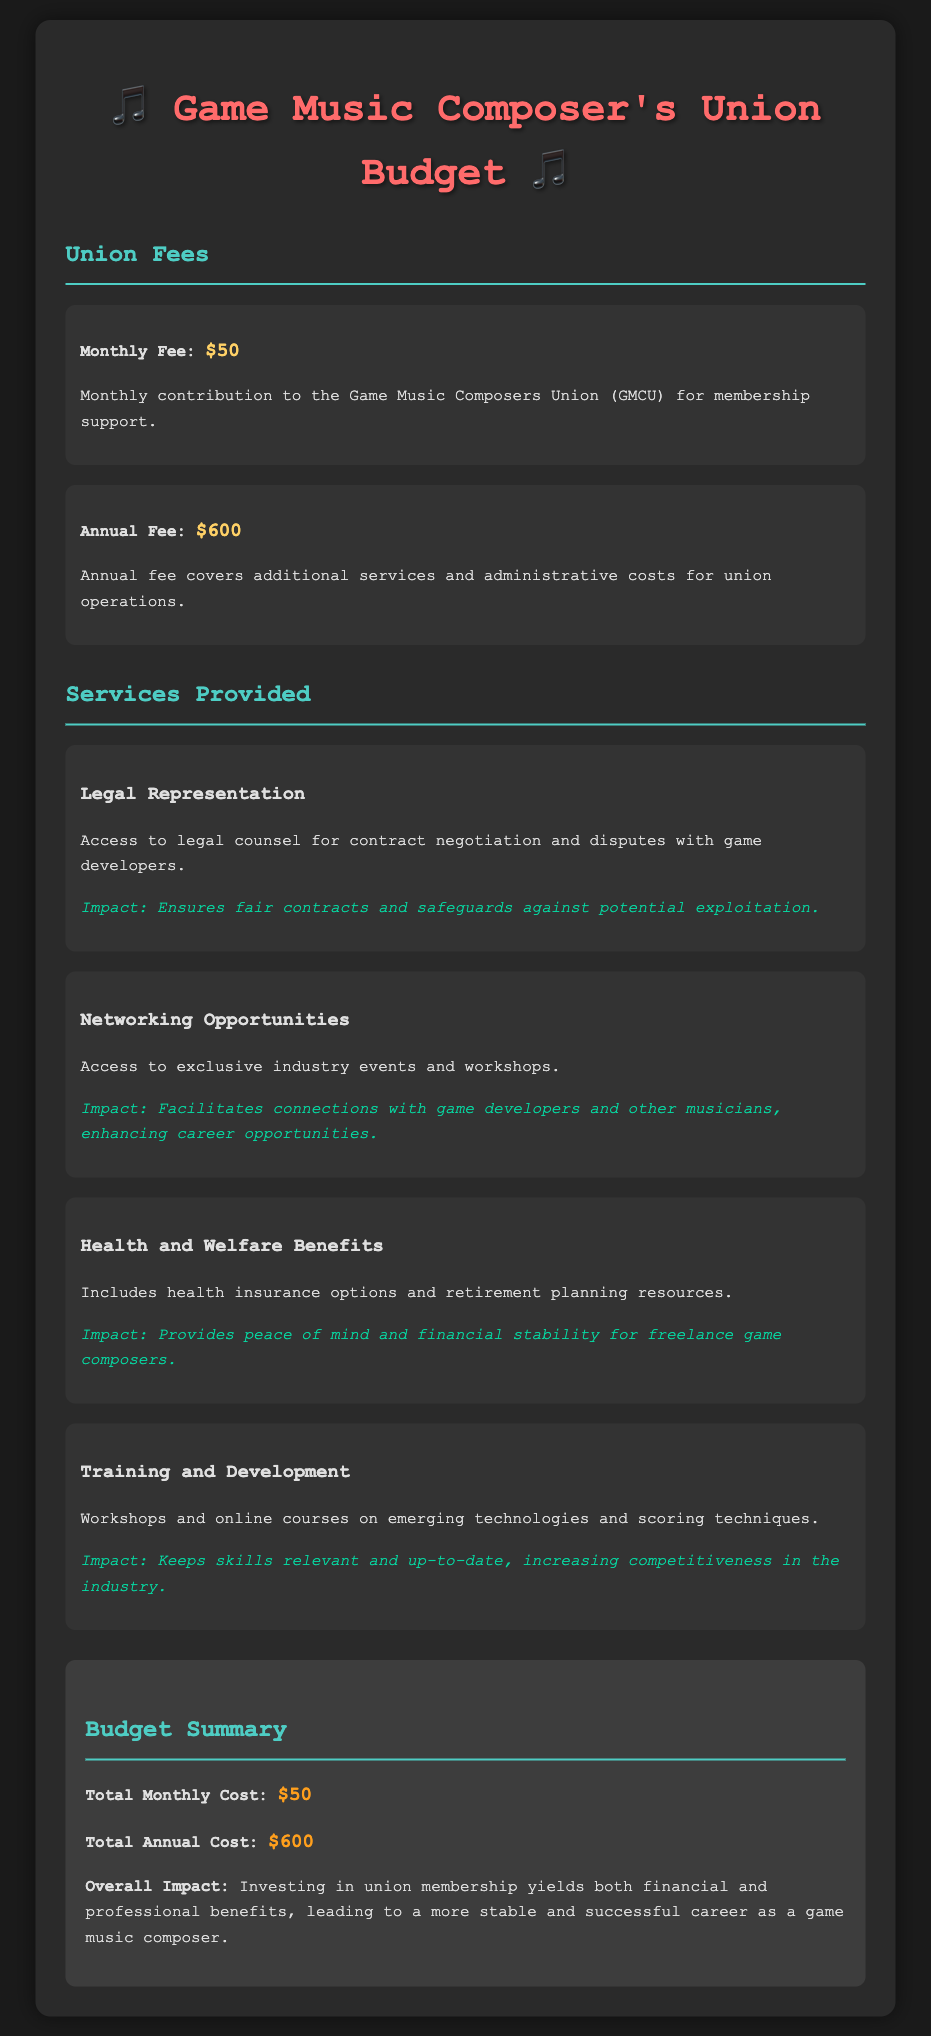What is the monthly fee? The monthly fee is explicitly stated in the document as $50.
Answer: $50 What is the annual fee? The annual fee is detailed in the budget breakdown as $600.
Answer: $600 What type of representation does the union provide? The document mentions "Legal Representation" as a service provided by the union.
Answer: Legal Representation Which benefit includes health insurance options? The health and welfare benefits section covers "Health Insurance options."
Answer: Health and Welfare Benefits What is one impact of networking opportunities? The document indicates that networking opportunities enhance career opportunities.
Answer: Enhances career opportunities How much is the total annual cost? The total annual cost is summarized in the budget as $600.
Answer: $600 What is the overall impact of investing in union membership? The document states that investing in union membership leads to a more stable and successful career.
Answer: More stable and successful career Which service helps keep skills relevant? The training and development section states that workshops help keep skills relevant.
Answer: Training and Development What is the total monthly cost? The total monthly cost is listed as $50 in the budget summary section.
Answer: $50 